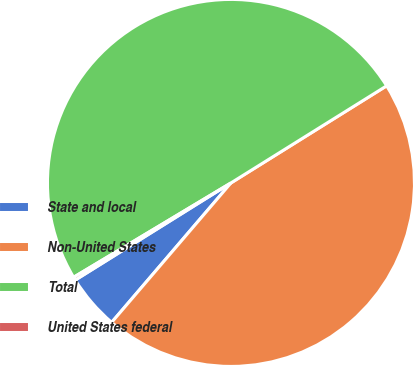<chart> <loc_0><loc_0><loc_500><loc_500><pie_chart><fcel>State and local<fcel>Non-United States<fcel>Total<fcel>United States federal<nl><fcel>4.86%<fcel>45.14%<fcel>49.72%<fcel>0.28%<nl></chart> 